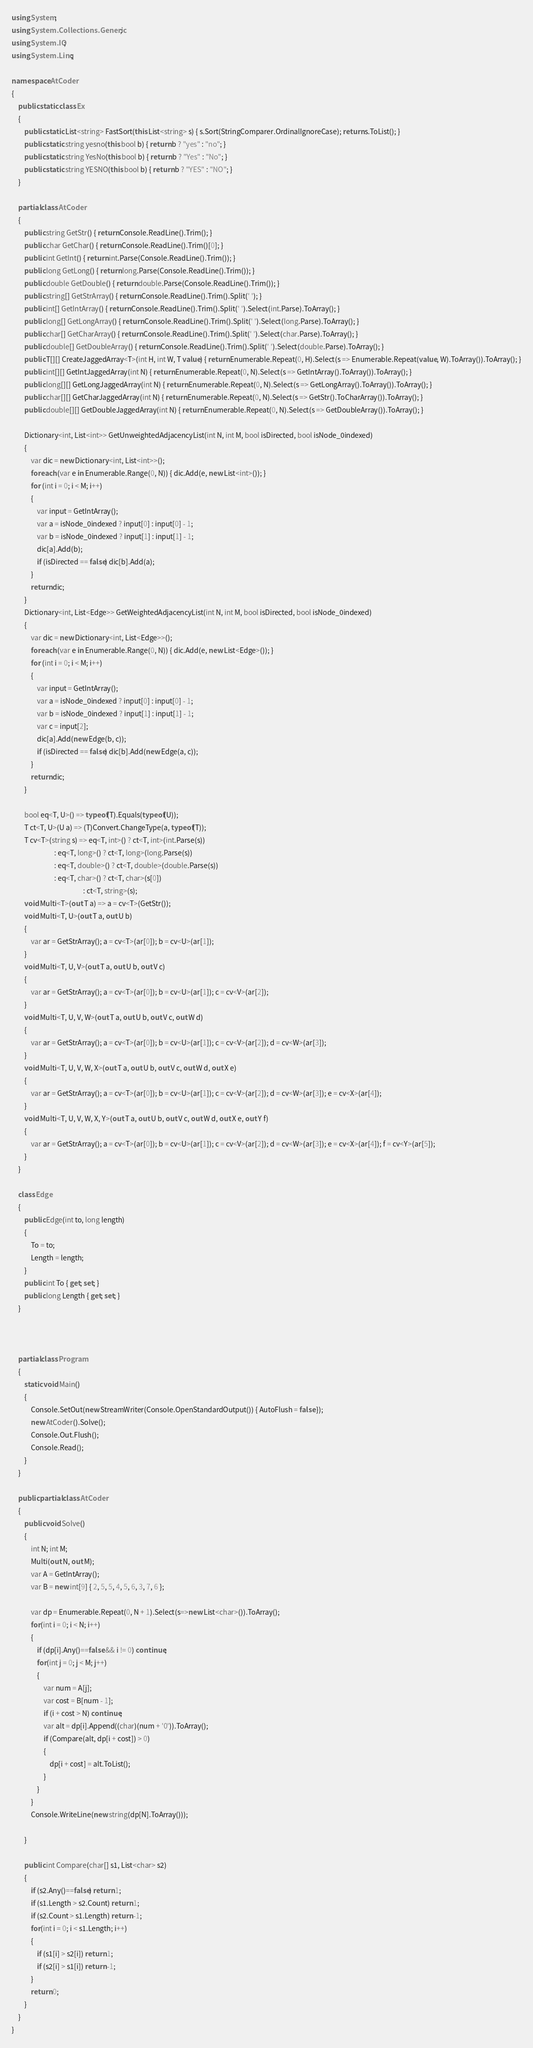Convert code to text. <code><loc_0><loc_0><loc_500><loc_500><_C#_>using System;
using System.Collections.Generic;
using System.IO;
using System.Linq;

namespace AtCoder
{
    public static class Ex
    {
        public static List<string> FastSort(this List<string> s) { s.Sort(StringComparer.OrdinalIgnoreCase); return s.ToList(); }
        public static string yesno(this bool b) { return b ? "yes" : "no"; }
        public static string YesNo(this bool b) { return b ? "Yes" : "No"; }
        public static string YESNO(this bool b) { return b ? "YES" : "NO"; }
    }

    partial class AtCoder
    {
        public string GetStr() { return Console.ReadLine().Trim(); }
        public char GetChar() { return Console.ReadLine().Trim()[0]; }
        public int GetInt() { return int.Parse(Console.ReadLine().Trim()); }
        public long GetLong() { return long.Parse(Console.ReadLine().Trim()); }
        public double GetDouble() { return double.Parse(Console.ReadLine().Trim()); }
        public string[] GetStrArray() { return Console.ReadLine().Trim().Split(' '); }
        public int[] GetIntArray() { return Console.ReadLine().Trim().Split(' ').Select(int.Parse).ToArray(); }
        public long[] GetLongArray() { return Console.ReadLine().Trim().Split(' ').Select(long.Parse).ToArray(); }
        public char[] GetCharArray() { return Console.ReadLine().Trim().Split(' ').Select(char.Parse).ToArray(); }
        public double[] GetDoubleArray() { return Console.ReadLine().Trim().Split(' ').Select(double.Parse).ToArray(); }
        public T[][] CreateJaggedArray<T>(int H, int W, T value) { return Enumerable.Repeat(0, H).Select(s => Enumerable.Repeat(value, W).ToArray()).ToArray(); }
        public int[][] GetIntJaggedArray(int N) { return Enumerable.Repeat(0, N).Select(s => GetIntArray().ToArray()).ToArray(); }
        public long[][] GetLongJaggedArray(int N) { return Enumerable.Repeat(0, N).Select(s => GetLongArray().ToArray()).ToArray(); }
        public char[][] GetCharJaggedArray(int N) { return Enumerable.Repeat(0, N).Select(s => GetStr().ToCharArray()).ToArray(); }
        public double[][] GetDoubleJaggedArray(int N) { return Enumerable.Repeat(0, N).Select(s => GetDoubleArray()).ToArray(); }

        Dictionary<int, List<int>> GetUnweightedAdjacencyList(int N, int M, bool isDirected, bool isNode_0indexed)
        {
            var dic = new Dictionary<int, List<int>>();
            foreach (var e in Enumerable.Range(0, N)) { dic.Add(e, new List<int>()); }
            for (int i = 0; i < M; i++)
            {
                var input = GetIntArray();
                var a = isNode_0indexed ? input[0] : input[0] - 1;
                var b = isNode_0indexed ? input[1] : input[1] - 1;
                dic[a].Add(b);
                if (isDirected == false) dic[b].Add(a);
            }
            return dic;
        }
        Dictionary<int, List<Edge>> GetWeightedAdjacencyList(int N, int M, bool isDirected, bool isNode_0indexed)
        {
            var dic = new Dictionary<int, List<Edge>>();
            foreach (var e in Enumerable.Range(0, N)) { dic.Add(e, new List<Edge>()); }
            for (int i = 0; i < M; i++)
            {
                var input = GetIntArray();
                var a = isNode_0indexed ? input[0] : input[0] - 1;
                var b = isNode_0indexed ? input[1] : input[1] - 1;
                var c = input[2];
                dic[a].Add(new Edge(b, c));
                if (isDirected == false) dic[b].Add(new Edge(a, c));
            }
            return dic;
        }

        bool eq<T, U>() => typeof(T).Equals(typeof(U));
        T ct<T, U>(U a) => (T)Convert.ChangeType(a, typeof(T));
        T cv<T>(string s) => eq<T, int>() ? ct<T, int>(int.Parse(s))
                           : eq<T, long>() ? ct<T, long>(long.Parse(s))
                           : eq<T, double>() ? ct<T, double>(double.Parse(s))
                           : eq<T, char>() ? ct<T, char>(s[0])
                                             : ct<T, string>(s);
        void Multi<T>(out T a) => a = cv<T>(GetStr());
        void Multi<T, U>(out T a, out U b)
        {
            var ar = GetStrArray(); a = cv<T>(ar[0]); b = cv<U>(ar[1]);
        }
        void Multi<T, U, V>(out T a, out U b, out V c)
        {
            var ar = GetStrArray(); a = cv<T>(ar[0]); b = cv<U>(ar[1]); c = cv<V>(ar[2]);
        }
        void Multi<T, U, V, W>(out T a, out U b, out V c, out W d)
        {
            var ar = GetStrArray(); a = cv<T>(ar[0]); b = cv<U>(ar[1]); c = cv<V>(ar[2]); d = cv<W>(ar[3]);
        }
        void Multi<T, U, V, W, X>(out T a, out U b, out V c, out W d, out X e)
        {
            var ar = GetStrArray(); a = cv<T>(ar[0]); b = cv<U>(ar[1]); c = cv<V>(ar[2]); d = cv<W>(ar[3]); e = cv<X>(ar[4]);
        }
        void Multi<T, U, V, W, X, Y>(out T a, out U b, out V c, out W d, out X e, out Y f)
        {
            var ar = GetStrArray(); a = cv<T>(ar[0]); b = cv<U>(ar[1]); c = cv<V>(ar[2]); d = cv<W>(ar[3]); e = cv<X>(ar[4]); f = cv<Y>(ar[5]);
        }
    }

    class Edge
    {
        public Edge(int to, long length)
        {
            To = to;
            Length = length;
        }
        public int To { get; set; }
        public long Length { get; set; }
    }



    partial class Program
    {
        static void Main()
        {
            Console.SetOut(new StreamWriter(Console.OpenStandardOutput()) { AutoFlush = false });
            new AtCoder().Solve();
            Console.Out.Flush();
            Console.Read();
        }
    }

    public partial class AtCoder
    {
        public void Solve()
        {
            int N; int M;
            Multi(out N, out M);
            var A = GetIntArray();
            var B = new int[9] { 2, 5, 5, 4, 5, 6, 3, 7, 6 };

            var dp = Enumerable.Repeat(0, N + 1).Select(s=>new List<char>()).ToArray();
            for(int i = 0; i < N; i++)
            {
                if (dp[i].Any()==false && i != 0) continue;
                for(int j = 0; j < M; j++)
                {
                    var num = A[j];
                    var cost = B[num - 1];
                    if (i + cost > N) continue;
                    var alt = dp[i].Append((char)(num + '0')).ToArray();
                    if (Compare(alt, dp[i + cost]) > 0)
                    {
                        dp[i + cost] = alt.ToList();
                    }
                }
            }
            Console.WriteLine(new string(dp[N].ToArray()));

        }

        public int Compare(char[] s1, List<char> s2)
        {
            if (s2.Any()==false) return 1;
            if (s1.Length > s2.Count) return 1;
            if (s2.Count > s1.Length) return -1;
            for(int i = 0; i < s1.Length; i++)
            {
                if (s1[i] > s2[i]) return 1;
                if (s2[i] > s1[i]) return -1;
            }
            return 0;
        }
    }
}
</code> 